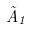<formula> <loc_0><loc_0><loc_500><loc_500>\tilde { A } _ { 1 }</formula> 